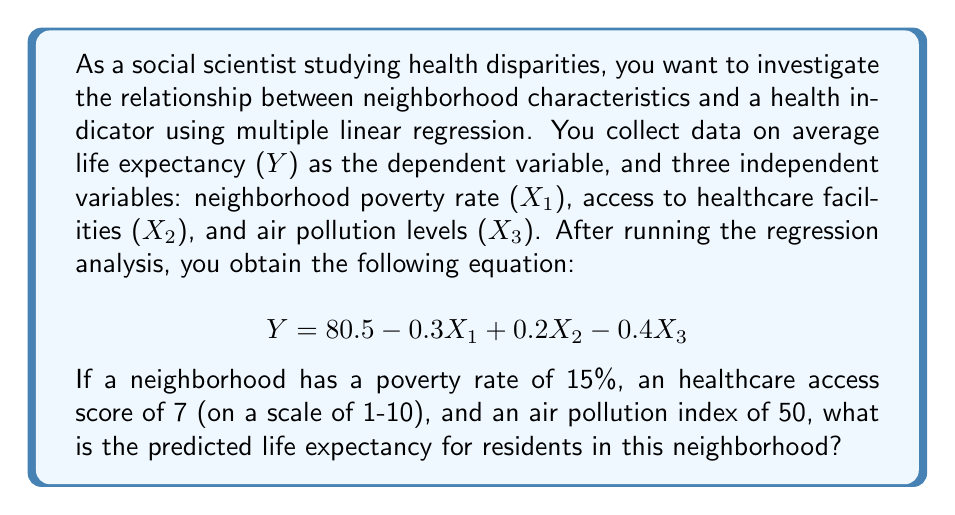Solve this math problem. To solve this problem, we'll follow these steps:

1. Identify the given information:
   - Regression equation: $Y = 80.5 - 0.3X_1 + 0.2X_2 - 0.4X_3$
   - $X_1$ (poverty rate) = 15%
   - $X_2$ (healthcare access score) = 7
   - $X_3$ (air pollution index) = 50

2. Substitute the values into the equation:
   $$ Y = 80.5 - 0.3(15) + 0.2(7) - 0.4(50) $$

3. Calculate each term:
   - $80.5$ (constant term)
   - $-0.3(15) = -4.5$
   - $0.2(7) = 1.4$
   - $-0.4(50) = -20$

4. Sum up all the terms:
   $$ Y = 80.5 - 4.5 + 1.4 - 20 $$
   $$ Y = 57.4 $$

Therefore, the predicted life expectancy for residents in this neighborhood is 57.4 years.
Answer: 57.4 years 